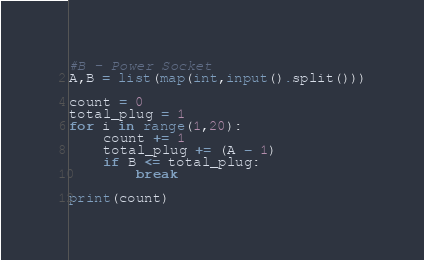<code> <loc_0><loc_0><loc_500><loc_500><_Python_>#B - Power Socket
A,B = list(map(int,input().split()))

count = 0
total_plug = 1
for i in range(1,20):
    count += 1
    total_plug += (A - 1)
    if B <= total_plug:
        break
        
print(count)</code> 